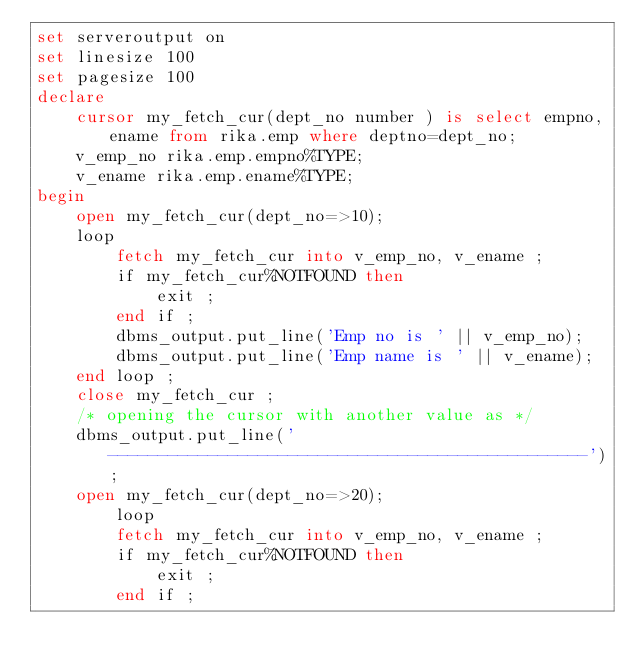Convert code to text. <code><loc_0><loc_0><loc_500><loc_500><_SQL_>set serveroutput on
set linesize 100
set pagesize 100
declare 
    cursor my_fetch_cur(dept_no number ) is select empno,ename from rika.emp where deptno=dept_no;
    v_emp_no rika.emp.empno%TYPE;
    v_ename rika.emp.ename%TYPE;
begin
    open my_fetch_cur(dept_no=>10);
    loop
        fetch my_fetch_cur into v_emp_no, v_ename ; 
        if my_fetch_cur%NOTFOUND then
            exit ;
        end if ;
        dbms_output.put_line('Emp no is ' || v_emp_no);
        dbms_output.put_line('Emp name is ' || v_ename);
    end loop ;
    close my_fetch_cur ;
    /* opening the cursor with another value as */
    dbms_output.put_line('------------------------------------------------');
    open my_fetch_cur(dept_no=>20);
        loop
        fetch my_fetch_cur into v_emp_no, v_ename ; 
        if my_fetch_cur%NOTFOUND then
            exit ;
        end if ;</code> 